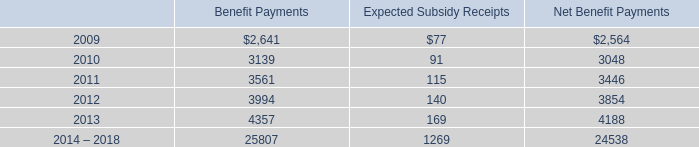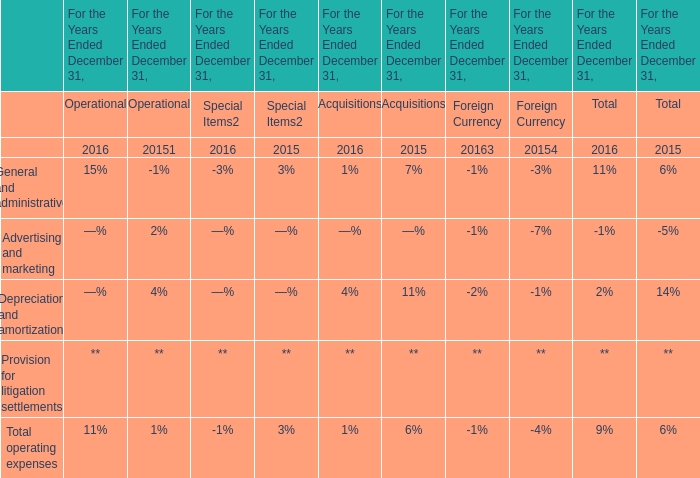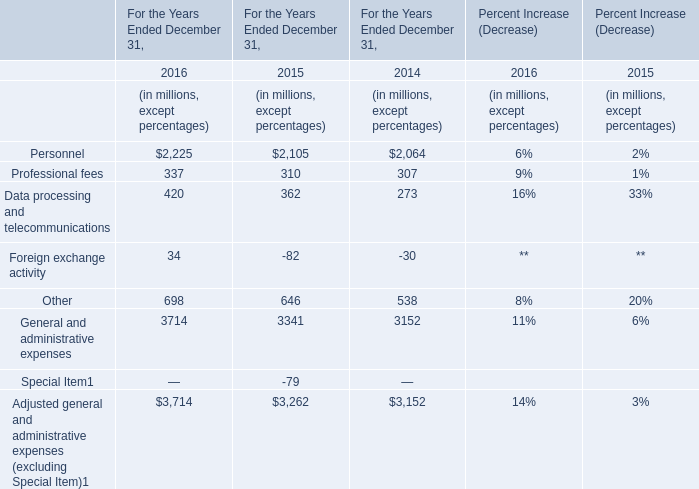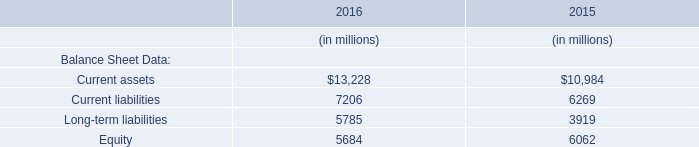what was the ratio of the accrued liability accrued liability related to the severance plan in 2008 to 2007 
Computations: (63863 / 56172)
Answer: 1.13692. 